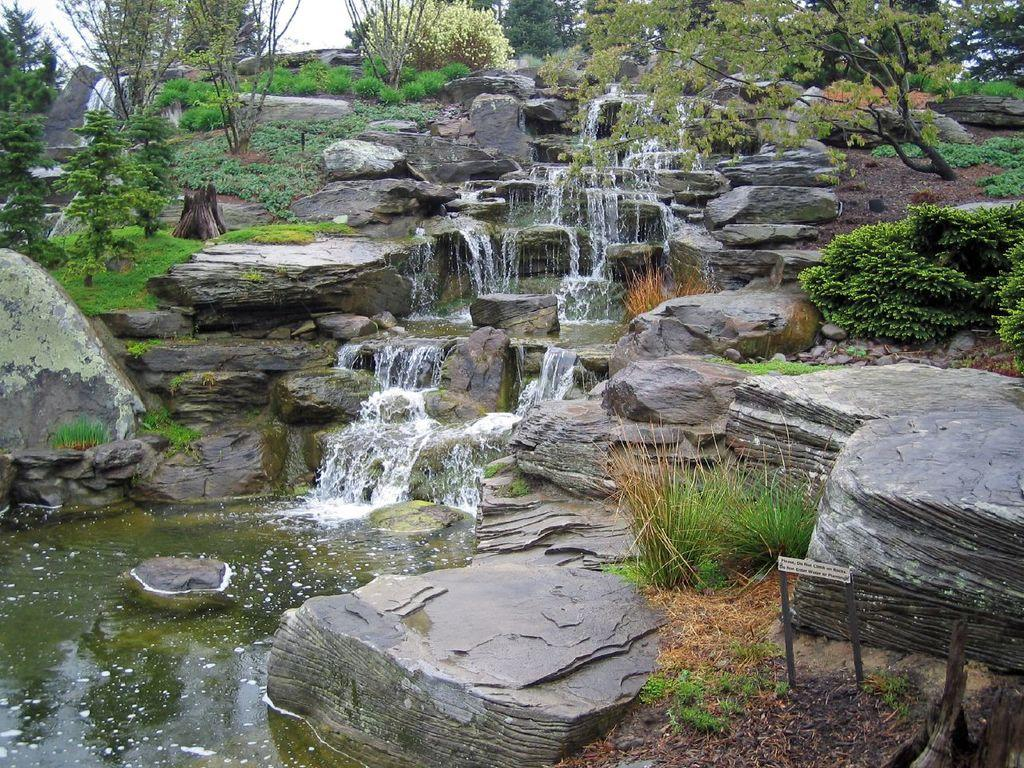What is the primary element in the image? There is water in the image. How is the water being depicted? Water is flowing from rocks in the image. What type of vegetation can be seen in the image? Trees and grass are visible in the image. How does the vegetation change in the background of the image? There are more trees in the background of the image. What else can be seen in the background of the image? The sky is visible in the background of the image. What type of oatmeal is being served in the image? There is no oatmeal present in the image; it features water flowing from rocks, trees, grass, and the sky. 